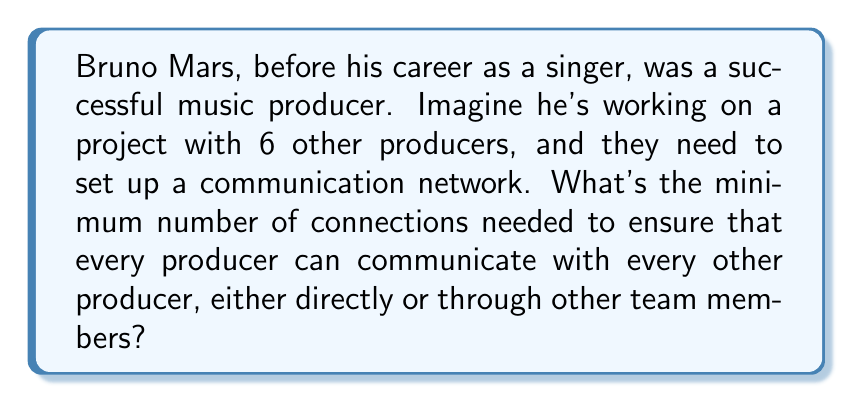What is the answer to this math problem? To solve this problem, we can use the concept of a minimum spanning tree from graph theory.

1) First, we need to understand that the producers form the vertices of our graph, and the connections between them are the edges.

2) The total number of producers, including Bruno Mars, is 7.

3) A minimum spanning tree is a tree that connects all vertices with the minimum number of edges. In a tree, the number of edges is always one less than the number of vertices.

4) Therefore, the minimum number of connections needed can be calculated using the formula:

   $$\text{Minimum connections} = n - 1$$

   Where $n$ is the number of vertices (producers in this case).

5) Substituting our value:

   $$\text{Minimum connections} = 7 - 1 = 6$$

This solution ensures that all producers are connected, either directly or indirectly, with the minimum number of connections. Any fewer connections would result in at least one producer being isolated from the network.

[asy]
unitsize(30);
pair[] points = {(0,0), (1,0), (cos(2pi/3),sin(2pi/3)), (cos(4pi/3),sin(4pi/3)), (2,0), (2*cos(2pi/3),2*sin(2pi/3)), (2*cos(4pi/3),2*sin(4pi/3))};
for(int i=0; i<7; ++i) {
  dot(points[i]);
}
draw(points[0]--points[1]);
draw(points[1]--points[2]);
draw(points[2]--points[3]);
draw(points[3]--points[4]);
draw(points[4]--points[5]);
draw(points[5]--points[6]);
label("Bruno", points[0], SW);
[/asy]

The diagram above shows one possible configuration of the minimum spanning tree for the 7 producers.
Answer: The minimum number of connections needed is 6. 